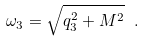<formula> <loc_0><loc_0><loc_500><loc_500>\omega _ { 3 } = \sqrt { q _ { 3 } ^ { 2 } + M ^ { 2 } } \ .</formula> 